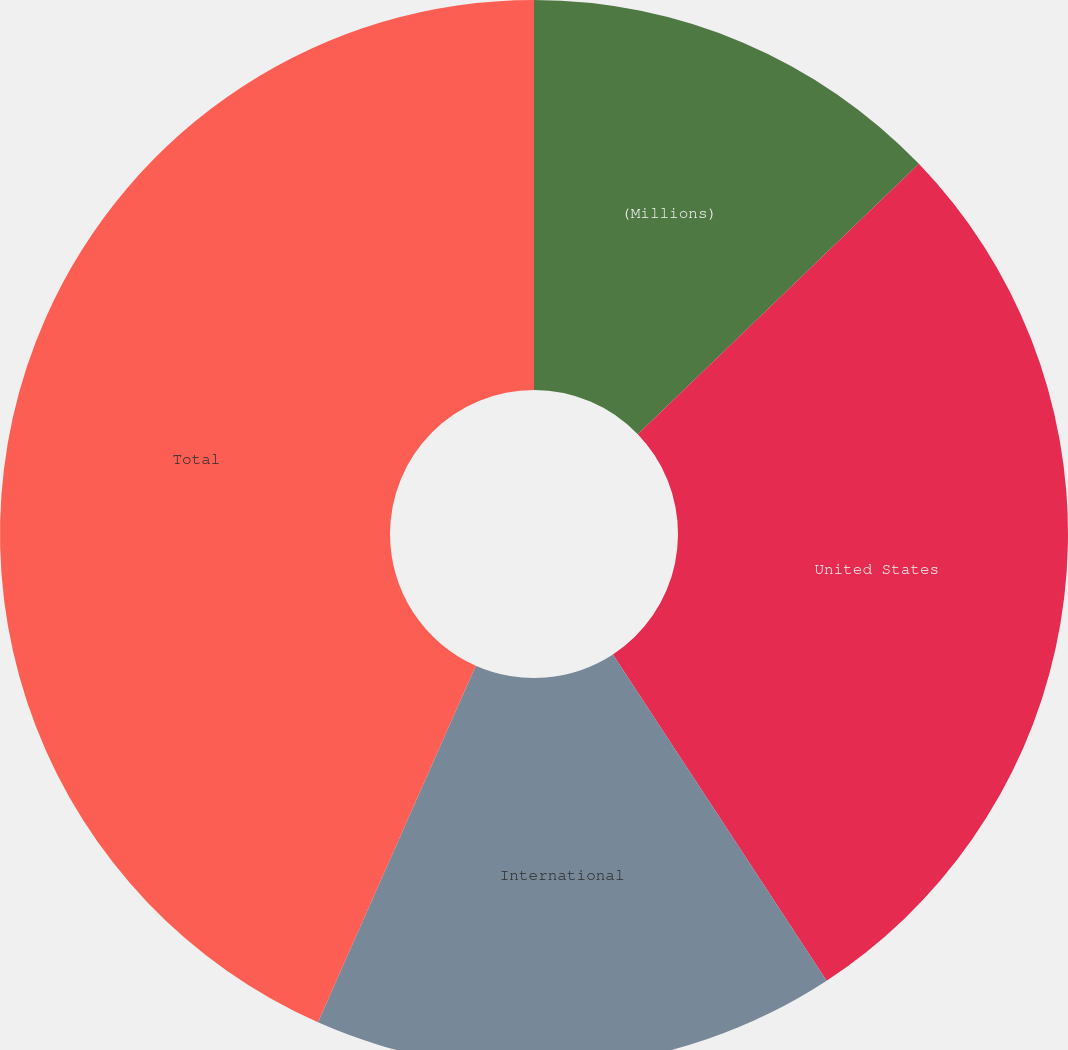<chart> <loc_0><loc_0><loc_500><loc_500><pie_chart><fcel>(Millions)<fcel>United States<fcel>International<fcel>Total<nl><fcel>12.81%<fcel>27.96%<fcel>15.86%<fcel>43.37%<nl></chart> 